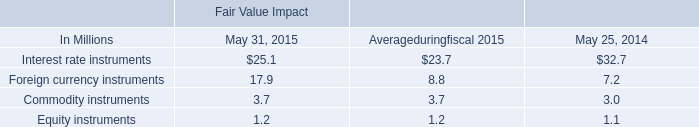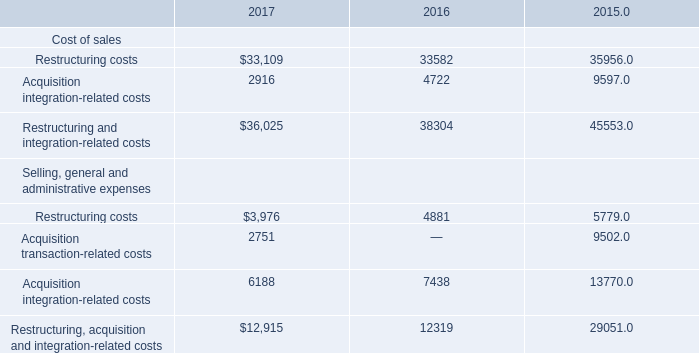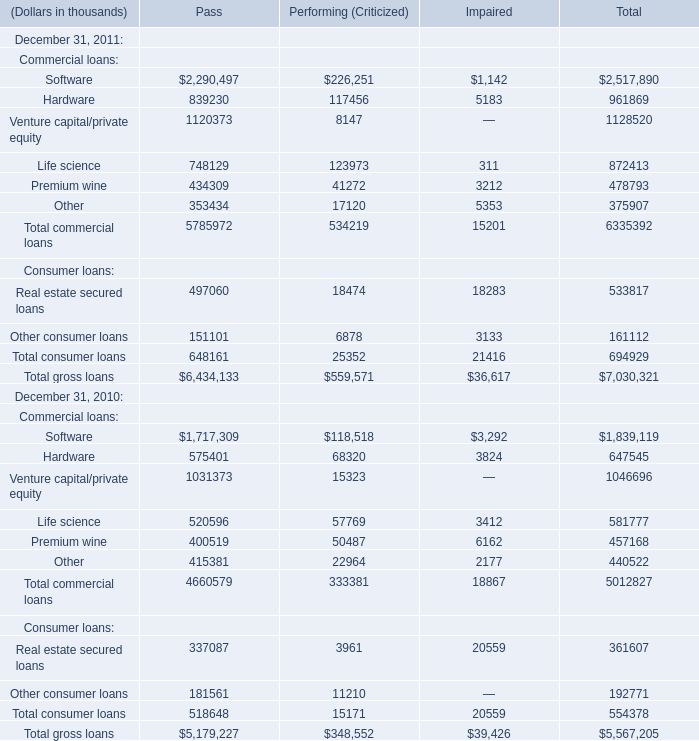What is the growing rate of Total commercial loans for Pass on December 31 in the year where Total consumer loans for Pass on December 31 is higher? 
Computations: ((5785972 - 4660579) / 4660579)
Answer: 0.24147. 